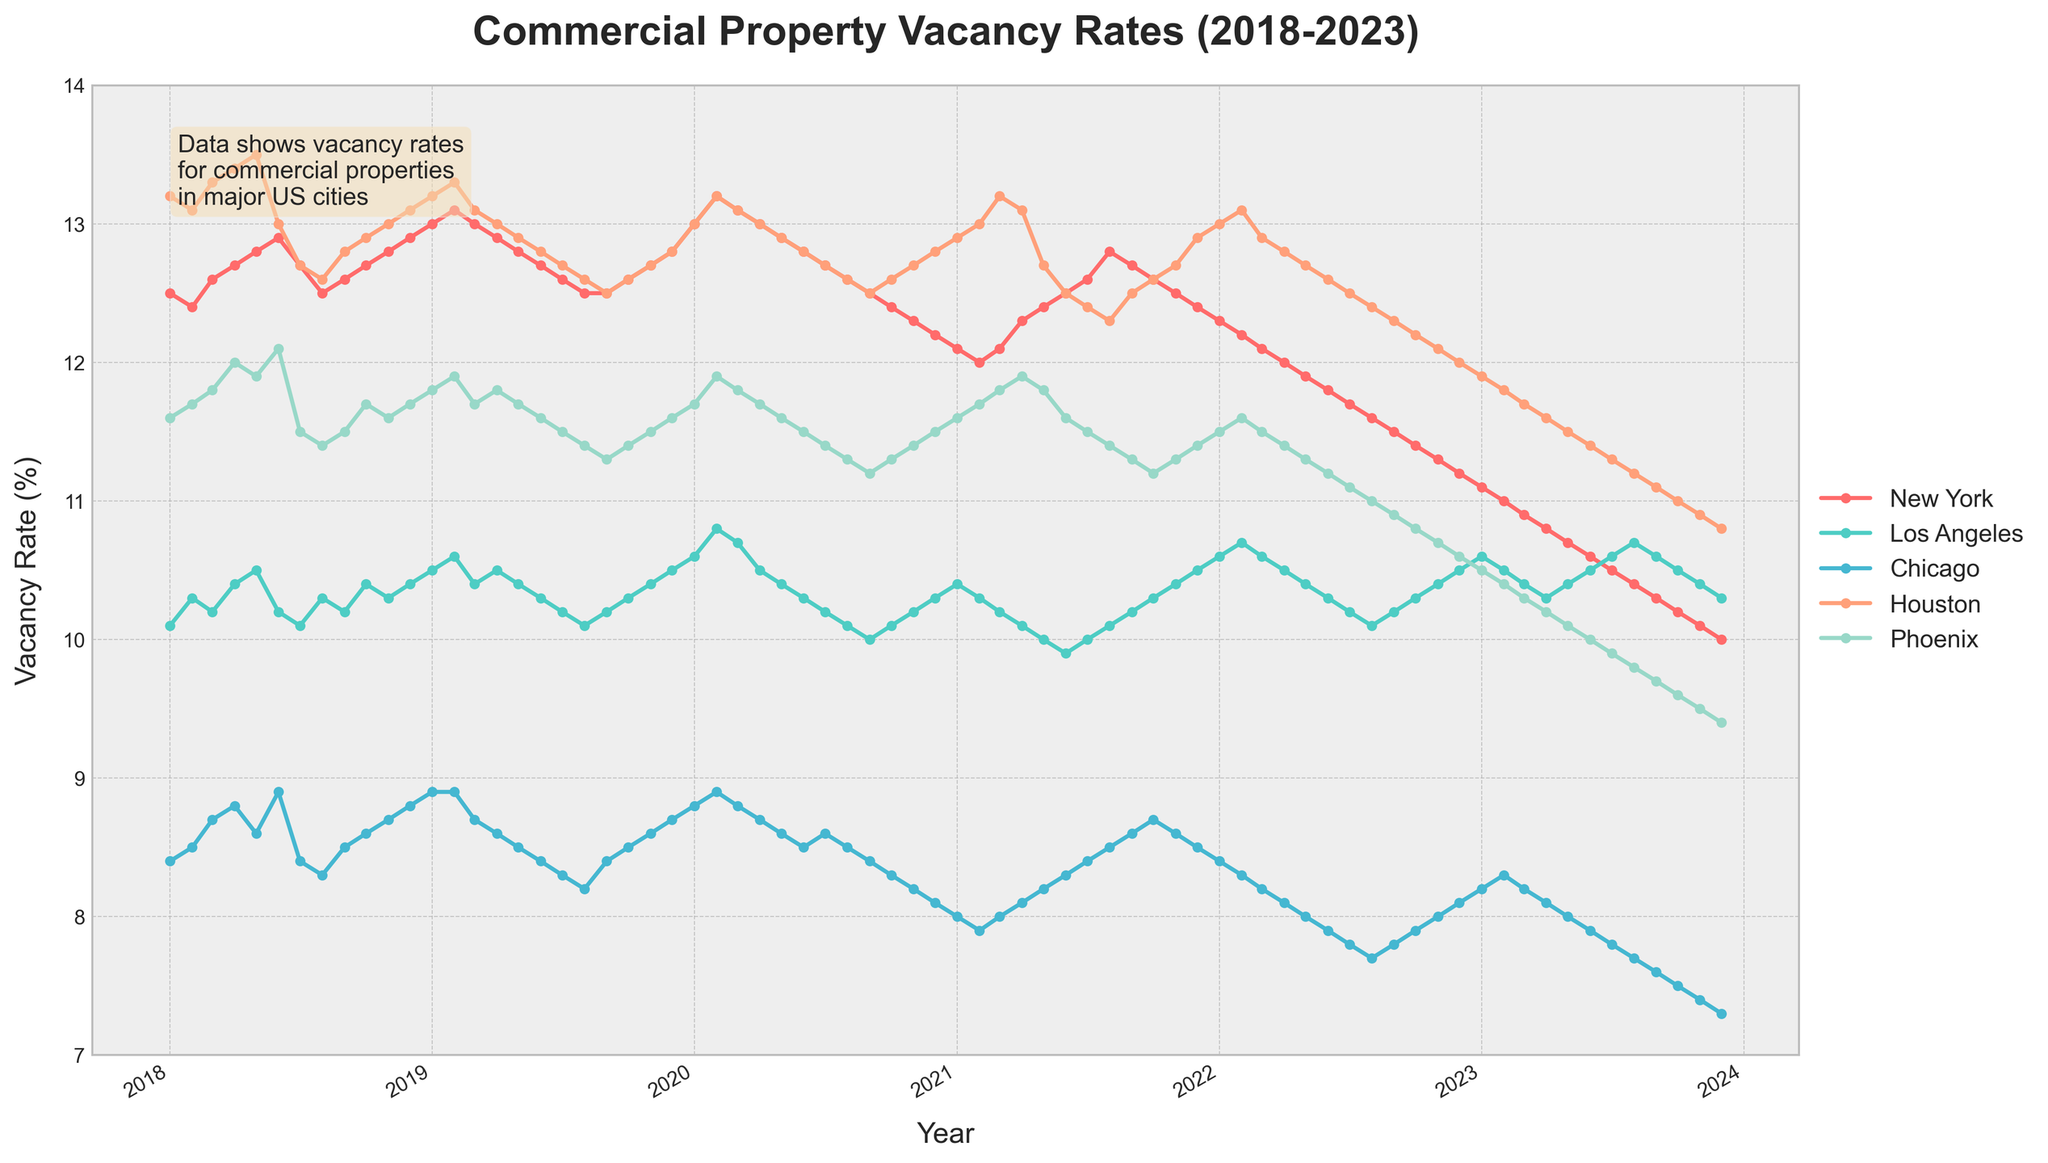What is the title of the plot? The title of the plot is located at the top of the figure and reads 'Commercial Property Vacancy Rates (2018-2023)'.
Answer: Commercial Property Vacancy Rates (2018-2023) Which city had the lowest vacancy rate in December 2023? Look at the December 2023 data points, compare them, and identify the lowest one. Phoenix has the lowest vacancy rate.
Answer: Phoenix What's the range of the y-axis? The range of an axis is determined by its minimum and maximum values. The y-axis ranges from 7% to 14%.
Answer: 7% to 14% Which year did New York have its highest vacancy rate, and what was the rate? Identify the highest point on the New York plot line, and then check the corresponding year. The highest vacancy rate for New York occurred in early 2020, peaking at around 13.2%.
Answer: Early 2020, around 13.2% How does the vacancy rate of Chicago in January 2018 compare to January 2023? Find both data points in January for the respective years and compare them. In January 2018, Chicago's vacancy rate was 8.4%, and in January 2023, it was 8.2%. The difference is small but shows a slight decrease.
Answer: January 2018: 8.4%, January 2023: 8.2% What trend do we observe in Phoenix's vacancy rates from 2020 to 2023? Trace the line for Phoenix from 2020 to 2023. The vacancy rate shows a continuous decreasing trend throughout this period, dropping from about 11.7% to 9.4%.
Answer: Continuous decrease Which city had the most stable vacancy rates over the 5-year period? Compare the fluctuations of the different cities’ plot lines. Los Angeles shows more stable vacancy rates with minimal fluctuations around the 10-11% mark.
Answer: Los Angeles During which year did Houston experience its sharpest decline in vacancy rates, and what is the approximate range of this decline? Examine the slope of the Houston line year by year. The sharpest decline is observed in 2023, where the vacancy rate drops from approximately 11.9% to around 10.8%.
Answer: 2023, approximately 1.1% Between which two consecutive months was the largest increase in vacancy rates observed for Los Angeles? Check the Los Angeles plot line and identify the largest upward jump between two consecutive points. The most significant increase occurs between January 2019 and February 2019, where it went from 10.5% to 10.6%.
Answer: January 2019 to February 2019 